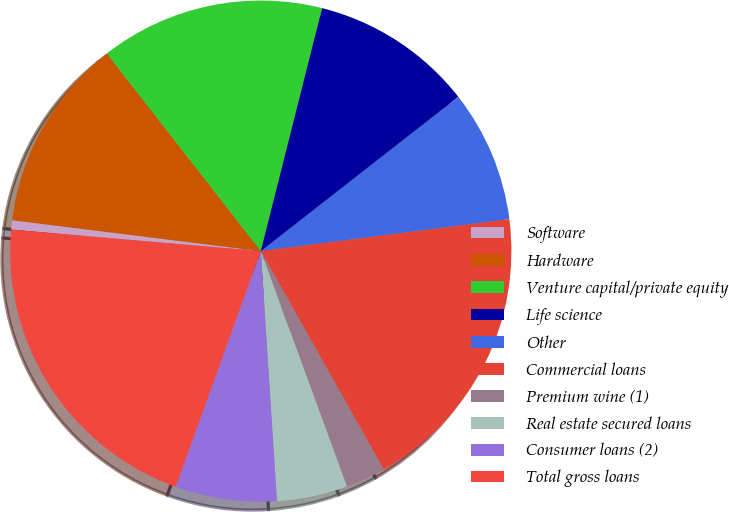Convert chart. <chart><loc_0><loc_0><loc_500><loc_500><pie_chart><fcel>Software<fcel>Hardware<fcel>Venture capital/private equity<fcel>Life science<fcel>Other<fcel>Commercial loans<fcel>Premium wine (1)<fcel>Real estate secured loans<fcel>Consumer loans (2)<fcel>Total gross loans<nl><fcel>0.6%<fcel>12.49%<fcel>14.47%<fcel>10.51%<fcel>8.52%<fcel>18.87%<fcel>2.58%<fcel>4.56%<fcel>6.54%<fcel>20.85%<nl></chart> 